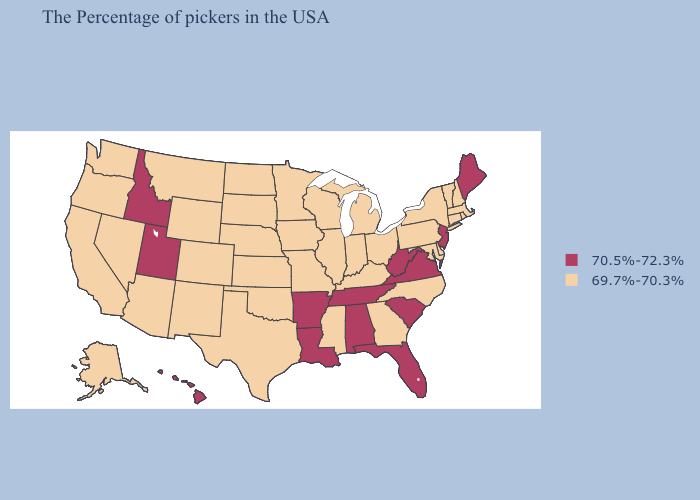How many symbols are there in the legend?
Quick response, please. 2. What is the value of Kansas?
Answer briefly. 69.7%-70.3%. Which states have the lowest value in the West?
Short answer required. Wyoming, Colorado, New Mexico, Montana, Arizona, Nevada, California, Washington, Oregon, Alaska. What is the lowest value in the South?
Short answer required. 69.7%-70.3%. Does Wyoming have the highest value in the USA?
Give a very brief answer. No. Does North Carolina have a lower value than Idaho?
Be succinct. Yes. Name the states that have a value in the range 70.5%-72.3%?
Concise answer only. Maine, New Jersey, Virginia, South Carolina, West Virginia, Florida, Alabama, Tennessee, Louisiana, Arkansas, Utah, Idaho, Hawaii. Among the states that border South Carolina , which have the lowest value?
Quick response, please. North Carolina, Georgia. Does South Dakota have the same value as Arizona?
Short answer required. Yes. What is the lowest value in the USA?
Answer briefly. 69.7%-70.3%. Which states hav the highest value in the West?
Write a very short answer. Utah, Idaho, Hawaii. What is the highest value in the USA?
Give a very brief answer. 70.5%-72.3%. Name the states that have a value in the range 70.5%-72.3%?
Concise answer only. Maine, New Jersey, Virginia, South Carolina, West Virginia, Florida, Alabama, Tennessee, Louisiana, Arkansas, Utah, Idaho, Hawaii. Name the states that have a value in the range 69.7%-70.3%?
Write a very short answer. Massachusetts, Rhode Island, New Hampshire, Vermont, Connecticut, New York, Delaware, Maryland, Pennsylvania, North Carolina, Ohio, Georgia, Michigan, Kentucky, Indiana, Wisconsin, Illinois, Mississippi, Missouri, Minnesota, Iowa, Kansas, Nebraska, Oklahoma, Texas, South Dakota, North Dakota, Wyoming, Colorado, New Mexico, Montana, Arizona, Nevada, California, Washington, Oregon, Alaska. 